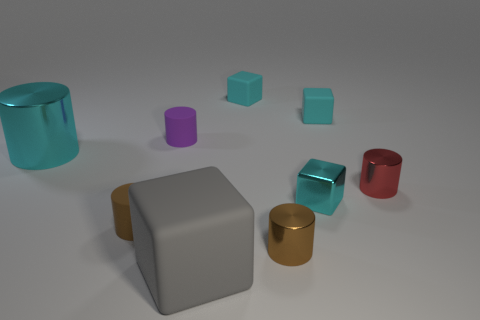What could be the function of the purple object? The purple object is a cylinder with a matte finish. It could potentially serve as a decorative piece or be part of a set for educational purposes, such as a tool for teaching geometry or color recognition. 